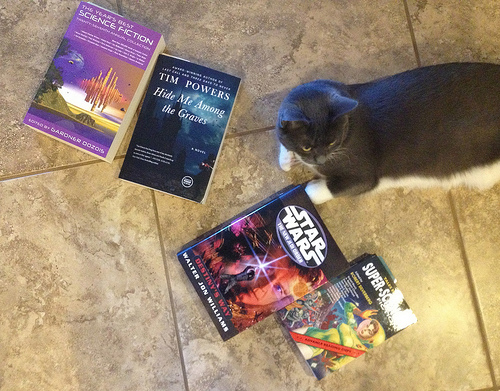<image>
Is there a cat to the right of the book? Yes. From this viewpoint, the cat is positioned to the right side relative to the book. Where is the cat in relation to the book? Is it on the book? No. The cat is not positioned on the book. They may be near each other, but the cat is not supported by or resting on top of the book. 